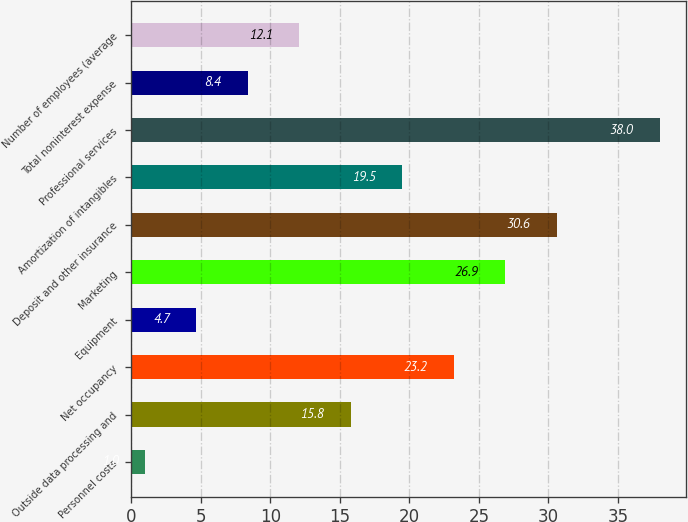Convert chart to OTSL. <chart><loc_0><loc_0><loc_500><loc_500><bar_chart><fcel>Personnel costs<fcel>Outside data processing and<fcel>Net occupancy<fcel>Equipment<fcel>Marketing<fcel>Deposit and other insurance<fcel>Amortization of intangibles<fcel>Professional services<fcel>Total noninterest expense<fcel>Number of employees (average<nl><fcel>1<fcel>15.8<fcel>23.2<fcel>4.7<fcel>26.9<fcel>30.6<fcel>19.5<fcel>38<fcel>8.4<fcel>12.1<nl></chart> 